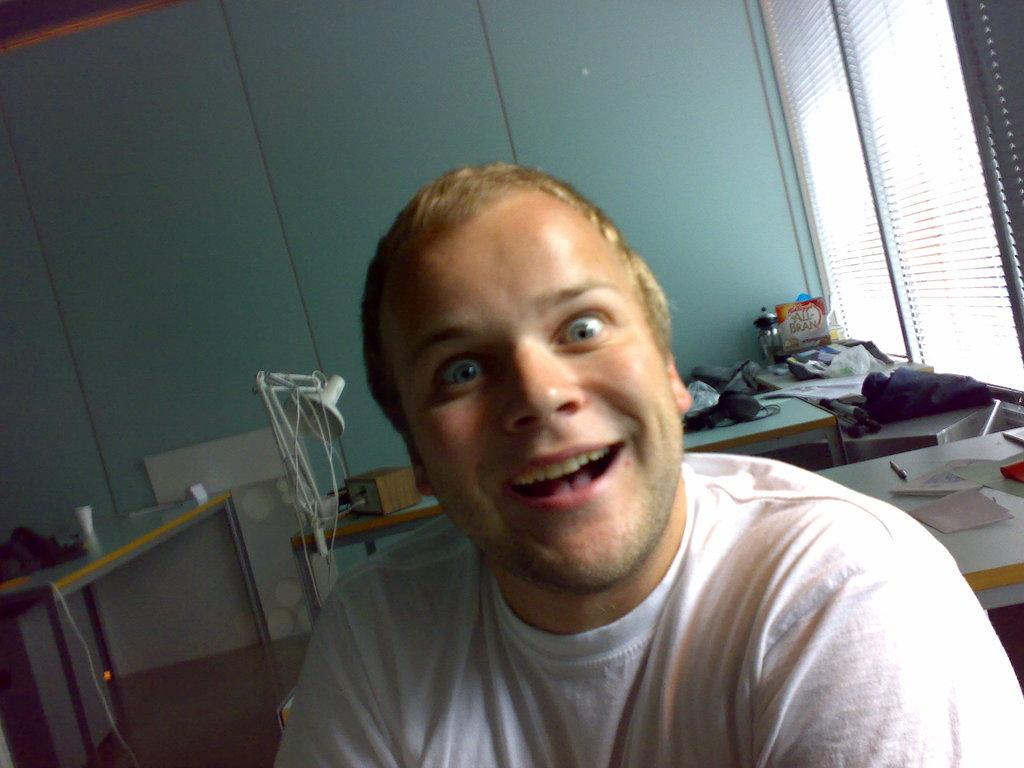Who is the main subject in the image? There is a man in the center of the image. What can be seen in the background of the image? There are tables, glasses, a headset, a light, clothes, a jar, windows, and a wall in the background of the image. What type of pin is the expert wearing in the image? There is no expert or pin present in the image. Are the police officers visible in the image? There is no mention of police officers in the provided facts, and therefore they are not present in the image. 